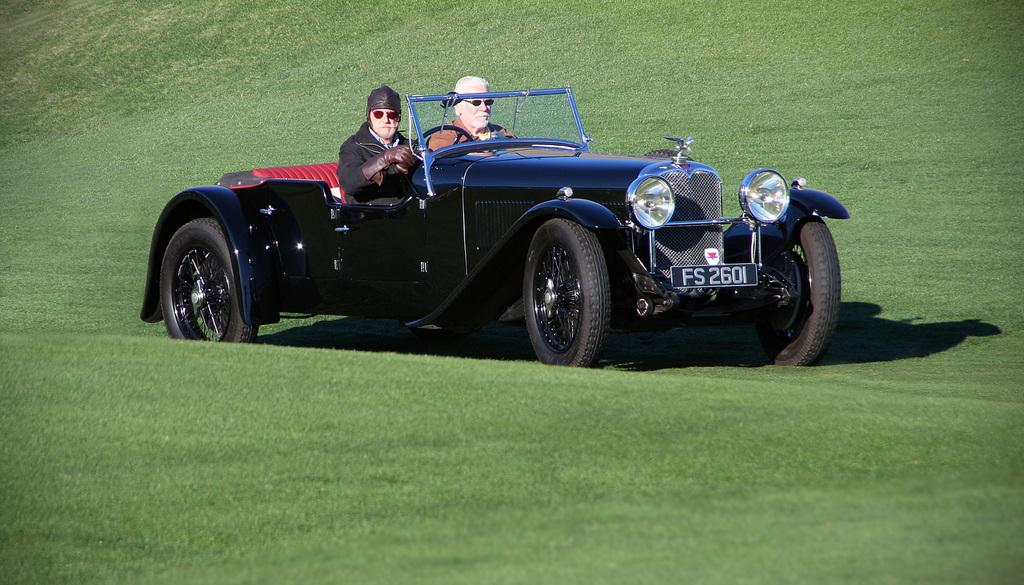What is the main subject of the image? There is a man in the image. What is the man wearing? The man is wearing a black jacket. What is the man doing in the image? The man is riding a black vehicle. What is the surface on which the vehicle is located? The vehicle is on grass. Who else is present in the image? There is another person sitting beside the man. Where can the receipt for the man's lunch be found in the image? There is no receipt or lunch mentioned in the image, so it cannot be found. 